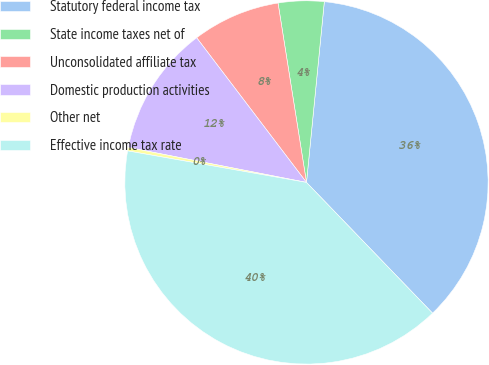Convert chart to OTSL. <chart><loc_0><loc_0><loc_500><loc_500><pie_chart><fcel>Statutory federal income tax<fcel>State income taxes net of<fcel>Unconsolidated affiliate tax<fcel>Domestic production activities<fcel>Other net<fcel>Effective income tax rate<nl><fcel>36.23%<fcel>4.07%<fcel>7.83%<fcel>11.58%<fcel>0.31%<fcel>39.99%<nl></chart> 